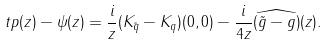Convert formula to latex. <formula><loc_0><loc_0><loc_500><loc_500>\ t p ( z ) - \psi ( z ) = \frac { i } { z } ( K _ { \tilde { q } } - K _ { q } ) ( 0 , 0 ) - \frac { i } { 4 z } \widehat { ( \tilde { g } - g ) } ( z ) .</formula> 